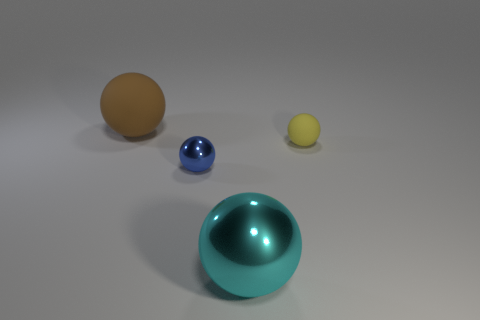Subtract 1 spheres. How many spheres are left? 3 Add 3 cyan metallic balls. How many objects exist? 7 Subtract 0 yellow cubes. How many objects are left? 4 Subtract all tiny blue matte objects. Subtract all small blue spheres. How many objects are left? 3 Add 4 cyan shiny spheres. How many cyan shiny spheres are left? 5 Add 3 gray objects. How many gray objects exist? 3 